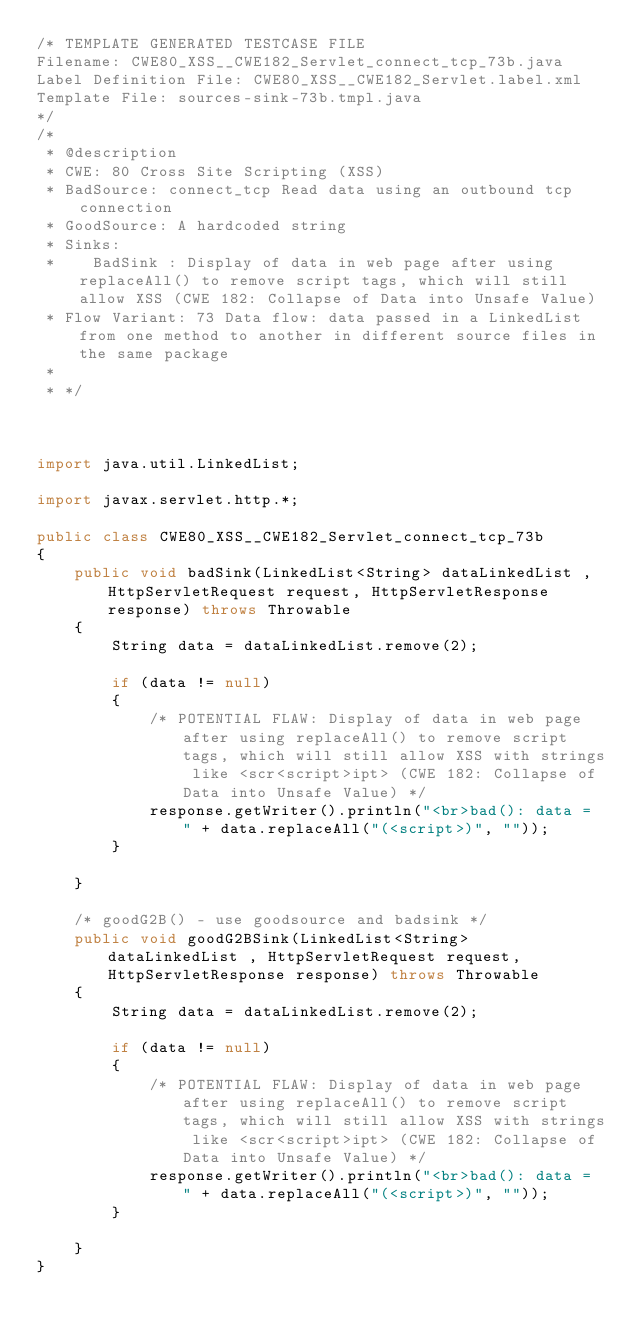<code> <loc_0><loc_0><loc_500><loc_500><_Java_>/* TEMPLATE GENERATED TESTCASE FILE
Filename: CWE80_XSS__CWE182_Servlet_connect_tcp_73b.java
Label Definition File: CWE80_XSS__CWE182_Servlet.label.xml
Template File: sources-sink-73b.tmpl.java
*/
/*
 * @description
 * CWE: 80 Cross Site Scripting (XSS)
 * BadSource: connect_tcp Read data using an outbound tcp connection
 * GoodSource: A hardcoded string
 * Sinks:
 *    BadSink : Display of data in web page after using replaceAll() to remove script tags, which will still allow XSS (CWE 182: Collapse of Data into Unsafe Value)
 * Flow Variant: 73 Data flow: data passed in a LinkedList from one method to another in different source files in the same package
 *
 * */



import java.util.LinkedList;

import javax.servlet.http.*;

public class CWE80_XSS__CWE182_Servlet_connect_tcp_73b
{
    public void badSink(LinkedList<String> dataLinkedList , HttpServletRequest request, HttpServletResponse response) throws Throwable
    {
        String data = dataLinkedList.remove(2);

        if (data != null)
        {
            /* POTENTIAL FLAW: Display of data in web page after using replaceAll() to remove script tags, which will still allow XSS with strings like <scr<script>ipt> (CWE 182: Collapse of Data into Unsafe Value) */
            response.getWriter().println("<br>bad(): data = " + data.replaceAll("(<script>)", ""));
        }

    }

    /* goodG2B() - use goodsource and badsink */
    public void goodG2BSink(LinkedList<String> dataLinkedList , HttpServletRequest request, HttpServletResponse response) throws Throwable
    {
        String data = dataLinkedList.remove(2);

        if (data != null)
        {
            /* POTENTIAL FLAW: Display of data in web page after using replaceAll() to remove script tags, which will still allow XSS with strings like <scr<script>ipt> (CWE 182: Collapse of Data into Unsafe Value) */
            response.getWriter().println("<br>bad(): data = " + data.replaceAll("(<script>)", ""));
        }

    }
}
</code> 